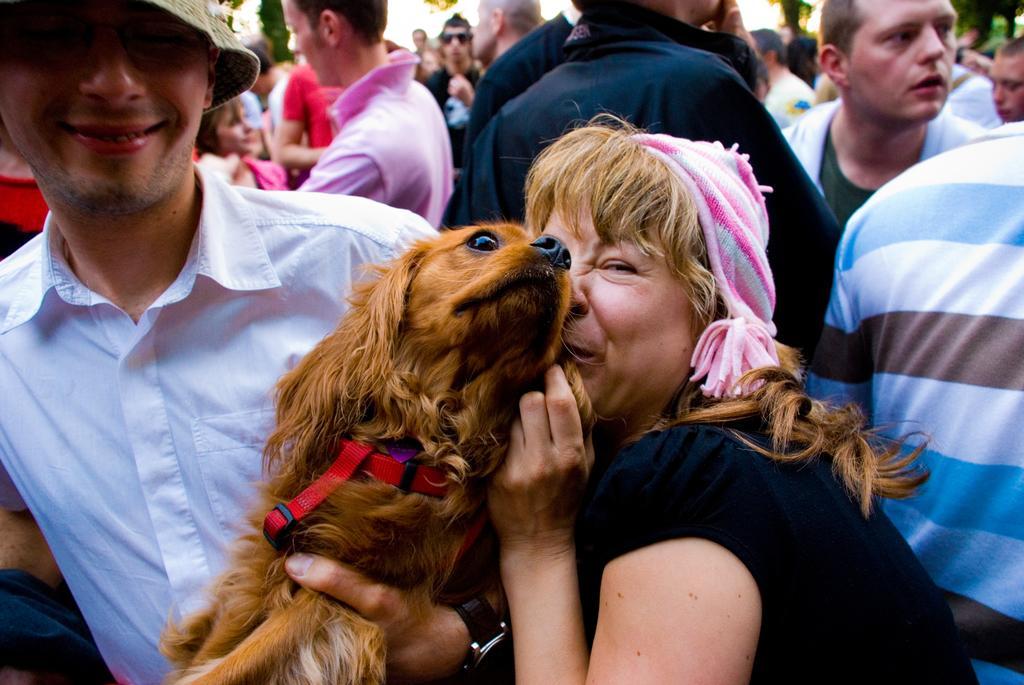Can you describe this image briefly? Group of people standing and these two persons holding dog and wear cap and this person smiling. 